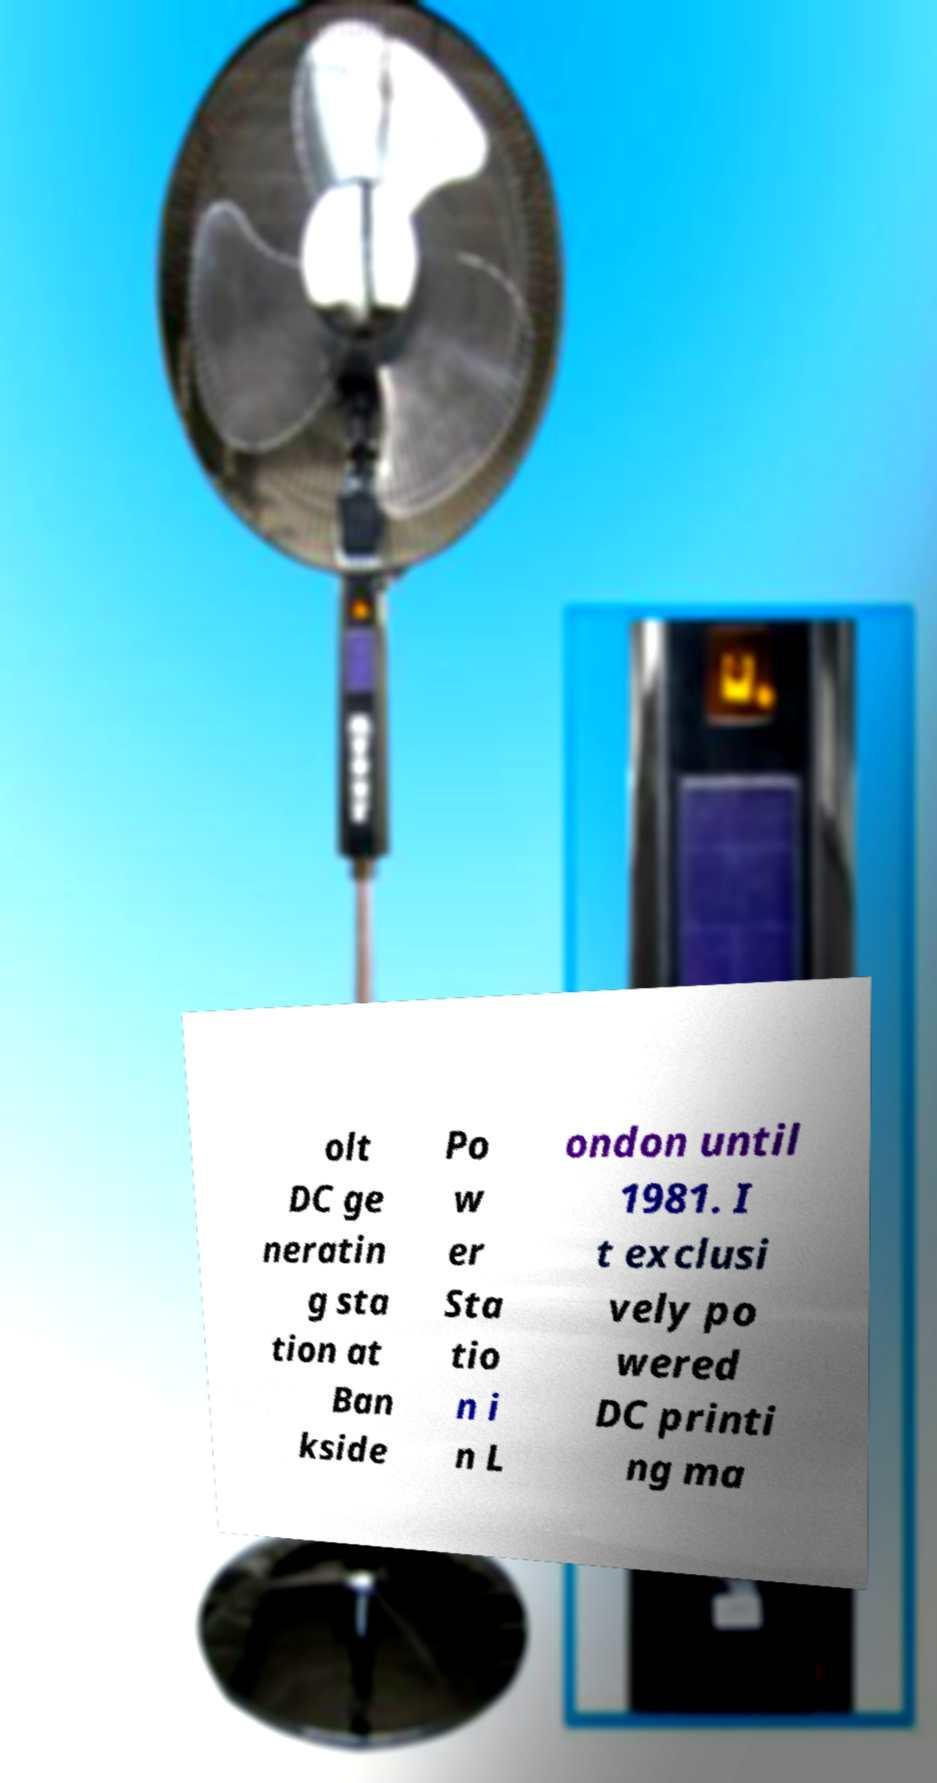Can you read and provide the text displayed in the image?This photo seems to have some interesting text. Can you extract and type it out for me? olt DC ge neratin g sta tion at Ban kside Po w er Sta tio n i n L ondon until 1981. I t exclusi vely po wered DC printi ng ma 